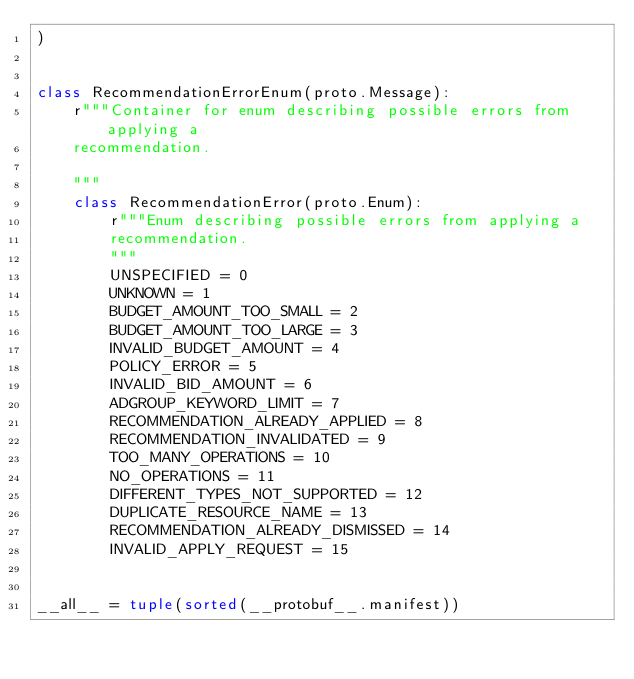Convert code to text. <code><loc_0><loc_0><loc_500><loc_500><_Python_>)


class RecommendationErrorEnum(proto.Message):
    r"""Container for enum describing possible errors from applying a
    recommendation.

    """
    class RecommendationError(proto.Enum):
        r"""Enum describing possible errors from applying a
        recommendation.
        """
        UNSPECIFIED = 0
        UNKNOWN = 1
        BUDGET_AMOUNT_TOO_SMALL = 2
        BUDGET_AMOUNT_TOO_LARGE = 3
        INVALID_BUDGET_AMOUNT = 4
        POLICY_ERROR = 5
        INVALID_BID_AMOUNT = 6
        ADGROUP_KEYWORD_LIMIT = 7
        RECOMMENDATION_ALREADY_APPLIED = 8
        RECOMMENDATION_INVALIDATED = 9
        TOO_MANY_OPERATIONS = 10
        NO_OPERATIONS = 11
        DIFFERENT_TYPES_NOT_SUPPORTED = 12
        DUPLICATE_RESOURCE_NAME = 13
        RECOMMENDATION_ALREADY_DISMISSED = 14
        INVALID_APPLY_REQUEST = 15


__all__ = tuple(sorted(__protobuf__.manifest))
</code> 